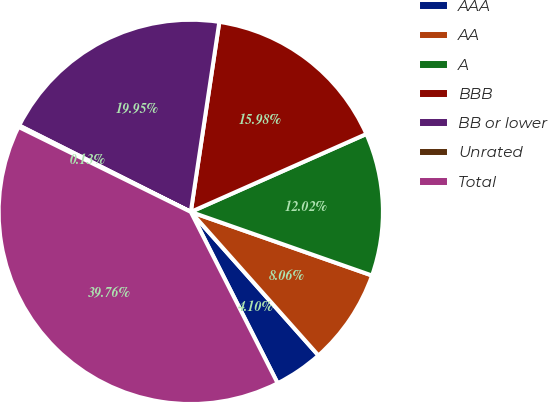Convert chart to OTSL. <chart><loc_0><loc_0><loc_500><loc_500><pie_chart><fcel>AAA<fcel>AA<fcel>A<fcel>BBB<fcel>BB or lower<fcel>Unrated<fcel>Total<nl><fcel>4.1%<fcel>8.06%<fcel>12.02%<fcel>15.98%<fcel>19.95%<fcel>0.13%<fcel>39.76%<nl></chart> 